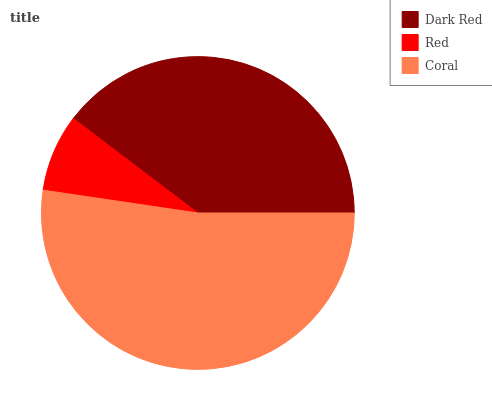Is Red the minimum?
Answer yes or no. Yes. Is Coral the maximum?
Answer yes or no. Yes. Is Coral the minimum?
Answer yes or no. No. Is Red the maximum?
Answer yes or no. No. Is Coral greater than Red?
Answer yes or no. Yes. Is Red less than Coral?
Answer yes or no. Yes. Is Red greater than Coral?
Answer yes or no. No. Is Coral less than Red?
Answer yes or no. No. Is Dark Red the high median?
Answer yes or no. Yes. Is Dark Red the low median?
Answer yes or no. Yes. Is Coral the high median?
Answer yes or no. No. Is Coral the low median?
Answer yes or no. No. 